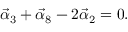<formula> <loc_0><loc_0><loc_500><loc_500>\vec { \alpha } _ { 3 } + \vec { \alpha } _ { 8 } - 2 \vec { \alpha } _ { 2 } = 0 .</formula> 